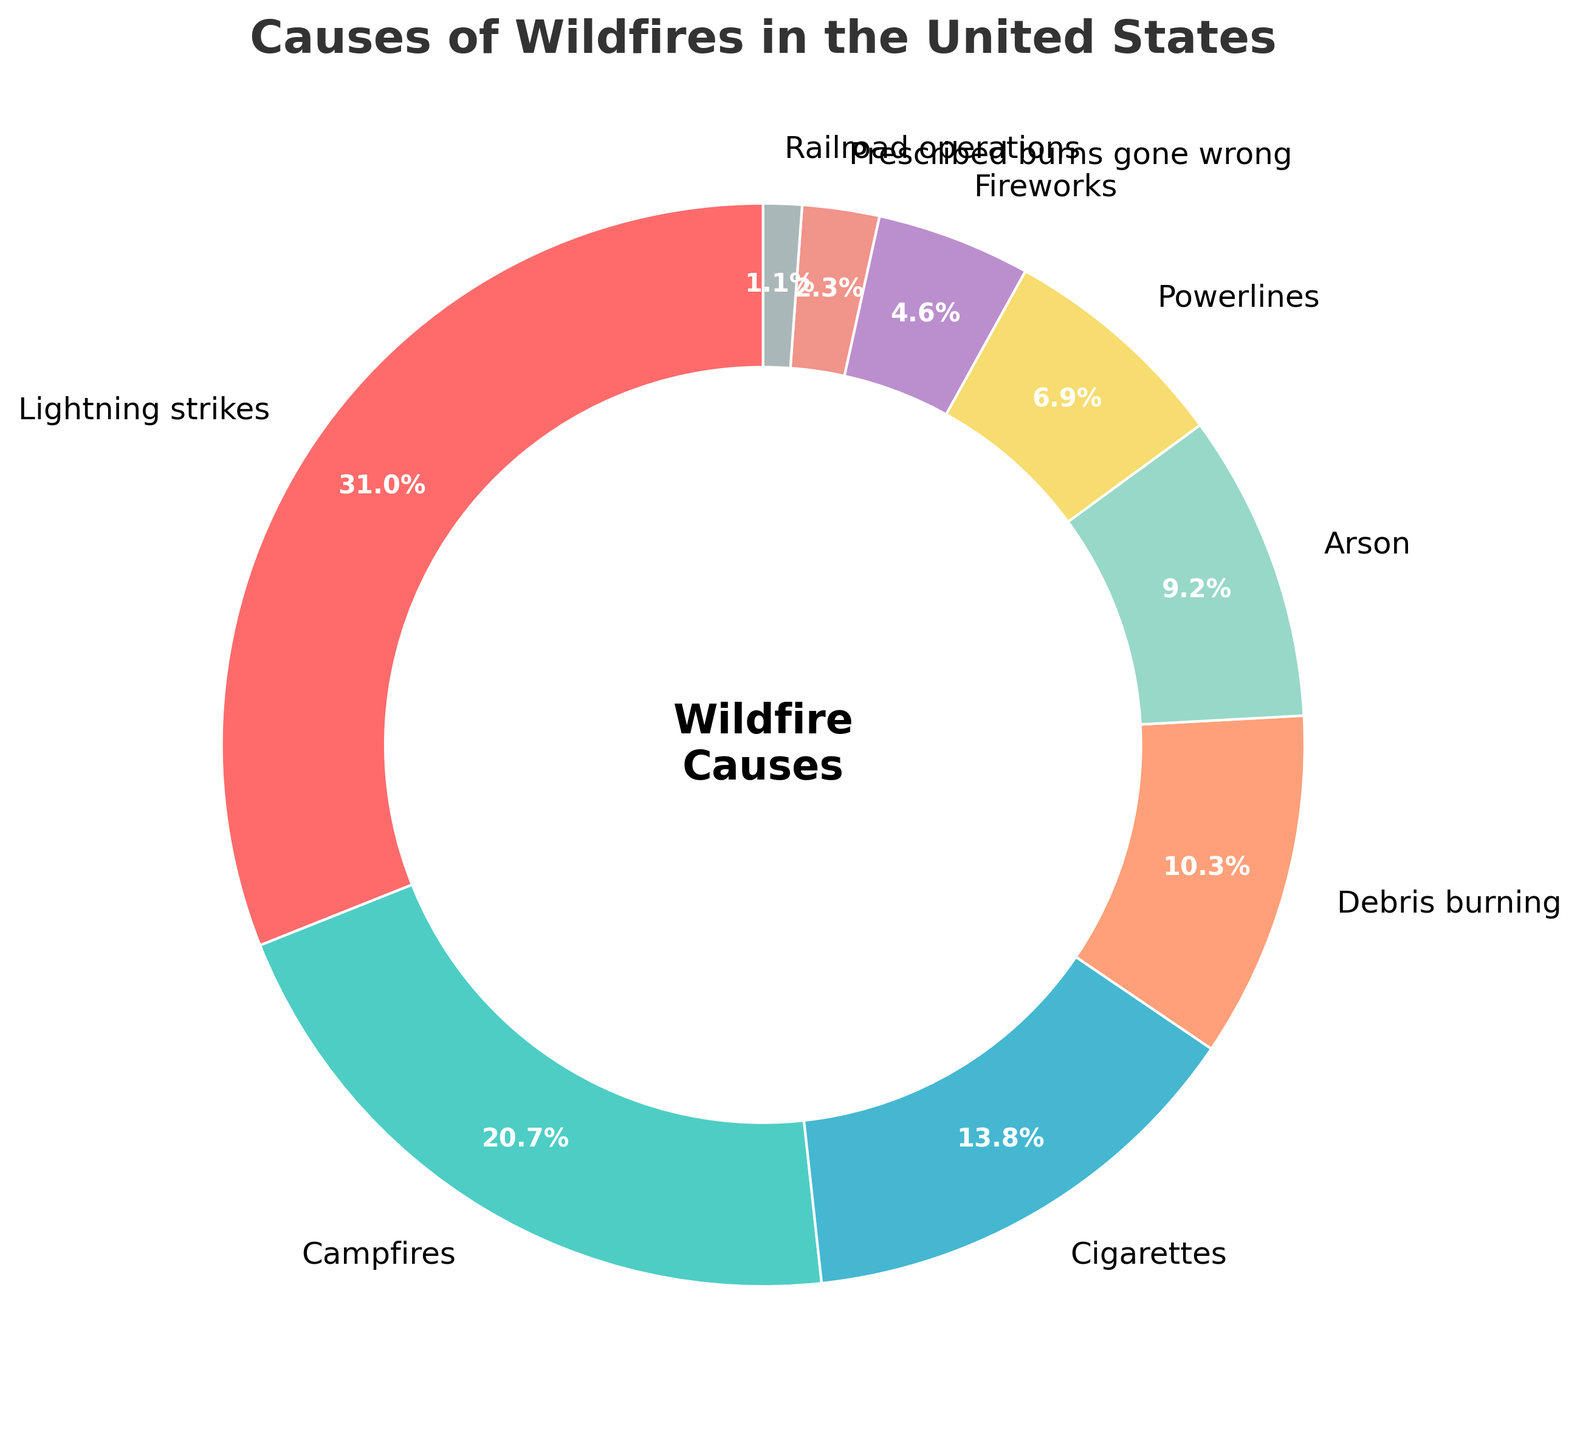Which cause of wildfire has the highest percentage? The pie chart shows that lightning strikes have the largest segment. This means that out of all the causes of wildfires listed, lightning strikes account for the highest percentage.
Answer: Lightning strikes How much more frequent are wildfires caused by campfires than by fireworks? The percentage of wildfires caused by campfires is 18%, and by fireworks is 4%. The difference between them is calculated as 18% - 4%.
Answer: 14% Which cause accounts for the least percentage of wildfires? The pie chart indicates that railroad operations occupy the smallest segment, meaning they account for the lowest percentage of wildfires.
Answer: Railroad operations Are campfires responsible for more wildfires than cigarettes and powerlines combined? Campfires cause 18% of wildfires. Cigarettes cause 12%, and powerlines cause 6%. The combined percentage for cigarettes and powerlines is 12% + 6% = 18%. Thus, the percentage caused by campfires is equal to the combined percentage of cigarettes and powerlines.
Answer: No What is the combined percentage of wildfires caused by accidental human activities (campfires, cigarettes, debris burning, prescribed burns gone wrong, and railroad operations)? Campfires cause 18%, cigarettes cause 12%, debris burning causes 9%, prescribed burns gone wrong cause 2%, and railroad operations cause 1%. Adding these gives 18% + 12% + 9% + 2% + 1% = 42%.
Answer: 42% Which cause of wildfire is represented by the green color in the chart? The green color in the pie chart corresponds to campfires, based on the visual representation.
Answer: Campfires How many more percent of wildfires are caused by lightning strikes than by arson? Lightning strikes cause 27% of wildfires, while arson causes 8%. The difference is 27% - 8%.
Answer: 19% Which three causes together account for more than 50% of wildfires? The three largest segments are lightning strikes (27%), campfires (18%), and cigarettes (12%). Adding these gives 27% + 18% + 12% = 57%, which is more than 50%.
Answer: Lightning strikes, Campfires, Cigarettes Compare the percentage of wildfires caused by debris burning to those caused by powerlines. Which is higher? Debris burning causes 9% of wildfires, while powerlines cause 6%. The percentage caused by debris burning is higher.
Answer: Debris burning 